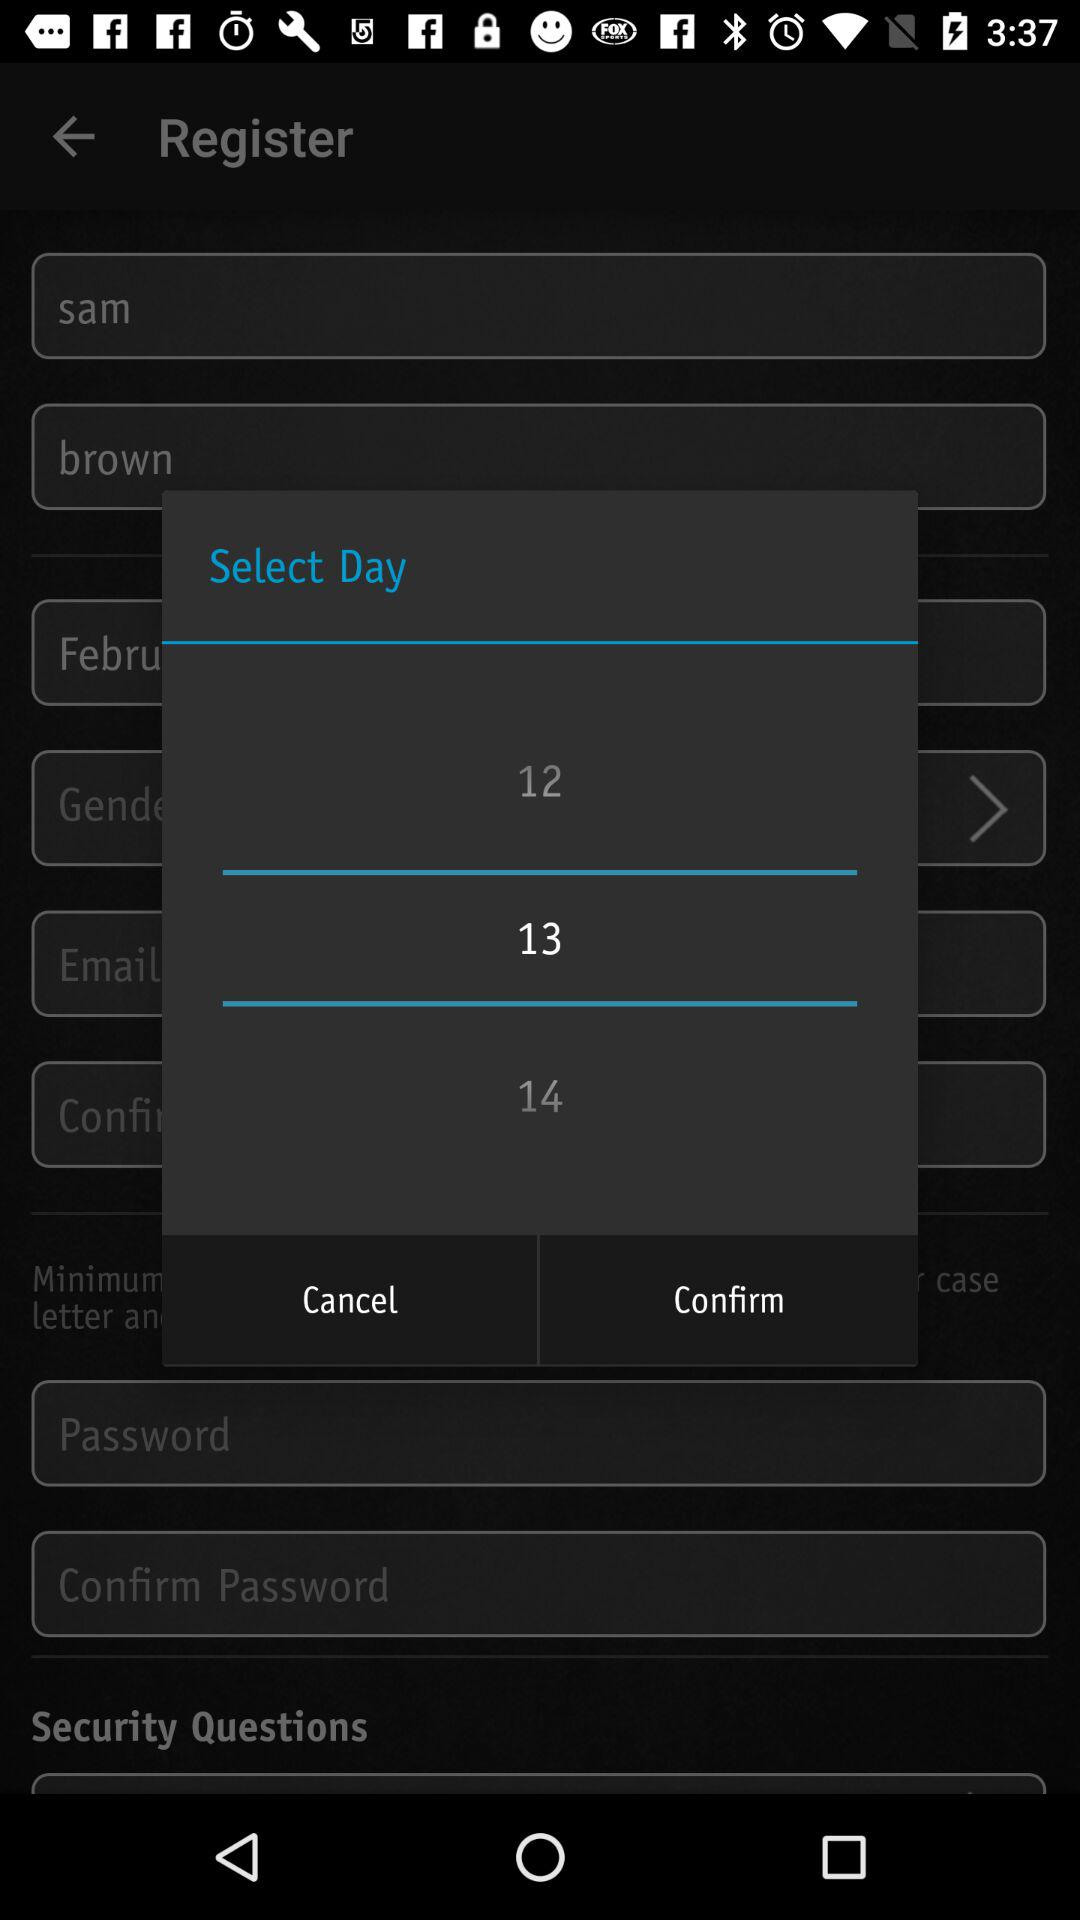What is the selected day? The selected day is 13. 